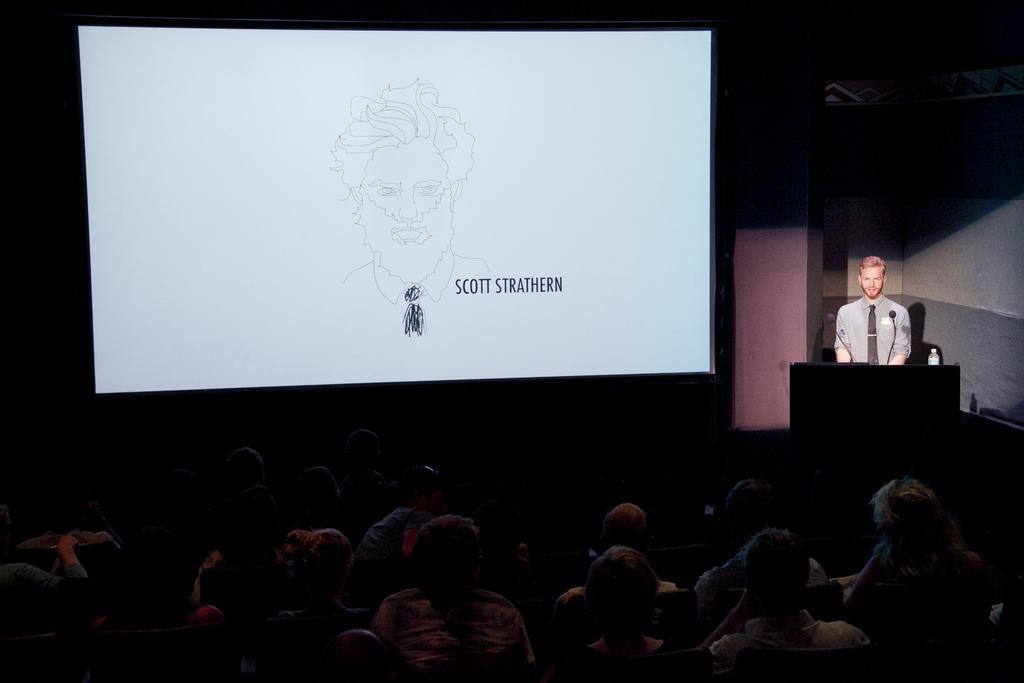Please provide a concise description of this image. In this picture we can see a man, standing on the right side at the speech desk and explaining something. In the front bottom side there is an audience sitting and listening to him. In the background we can see the white color big projector screen. 